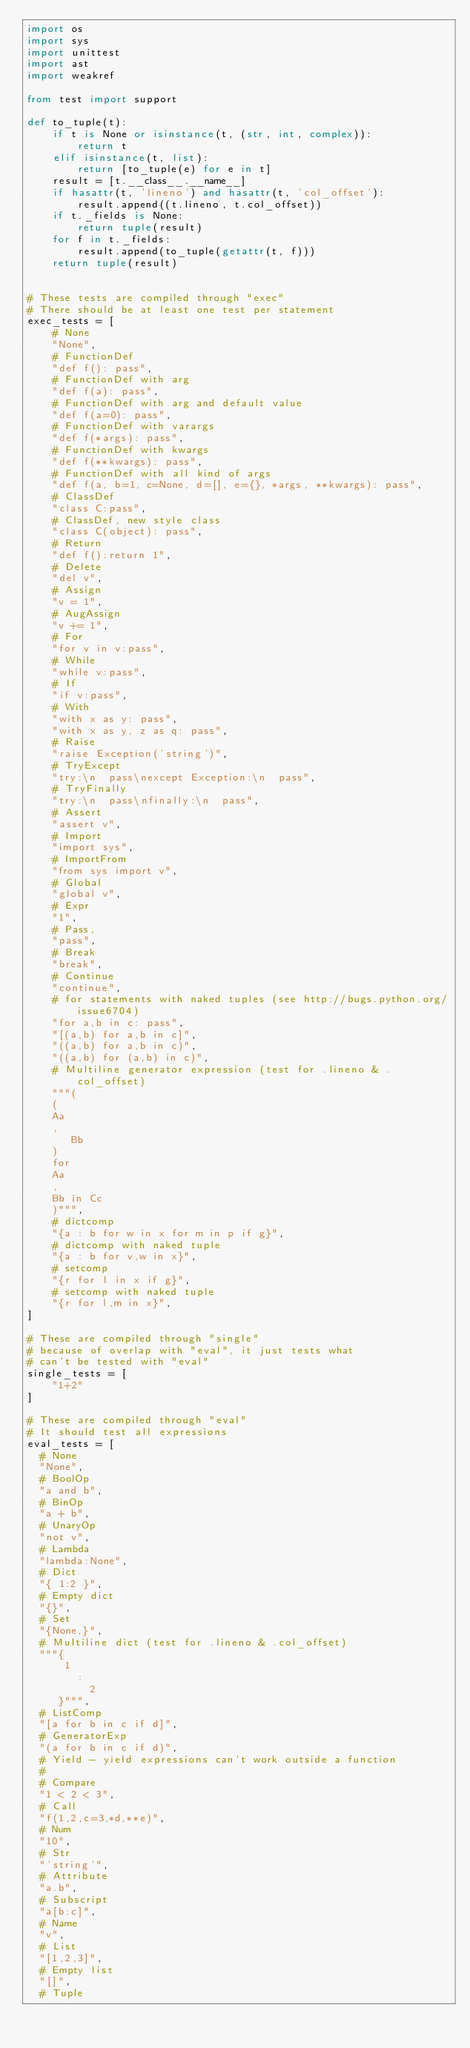<code> <loc_0><loc_0><loc_500><loc_500><_Python_>import os
import sys
import unittest
import ast
import weakref

from test import support

def to_tuple(t):
    if t is None or isinstance(t, (str, int, complex)):
        return t
    elif isinstance(t, list):
        return [to_tuple(e) for e in t]
    result = [t.__class__.__name__]
    if hasattr(t, 'lineno') and hasattr(t, 'col_offset'):
        result.append((t.lineno, t.col_offset))
    if t._fields is None:
        return tuple(result)
    for f in t._fields:
        result.append(to_tuple(getattr(t, f)))
    return tuple(result)


# These tests are compiled through "exec"
# There should be at least one test per statement
exec_tests = [
    # None
    "None",
    # FunctionDef
    "def f(): pass",
    # FunctionDef with arg
    "def f(a): pass",
    # FunctionDef with arg and default value
    "def f(a=0): pass",
    # FunctionDef with varargs
    "def f(*args): pass",
    # FunctionDef with kwargs
    "def f(**kwargs): pass",
    # FunctionDef with all kind of args
    "def f(a, b=1, c=None, d=[], e={}, *args, **kwargs): pass",
    # ClassDef
    "class C:pass",
    # ClassDef, new style class
    "class C(object): pass",
    # Return
    "def f():return 1",
    # Delete
    "del v",
    # Assign
    "v = 1",
    # AugAssign
    "v += 1",
    # For
    "for v in v:pass",
    # While
    "while v:pass",
    # If
    "if v:pass",
    # With
    "with x as y: pass",
    "with x as y, z as q: pass",
    # Raise
    "raise Exception('string')",
    # TryExcept
    "try:\n  pass\nexcept Exception:\n  pass",
    # TryFinally
    "try:\n  pass\nfinally:\n  pass",
    # Assert
    "assert v",
    # Import
    "import sys",
    # ImportFrom
    "from sys import v",
    # Global
    "global v",
    # Expr
    "1",
    # Pass,
    "pass",
    # Break
    "break",
    # Continue
    "continue",
    # for statements with naked tuples (see http://bugs.python.org/issue6704)
    "for a,b in c: pass",
    "[(a,b) for a,b in c]",
    "((a,b) for a,b in c)",
    "((a,b) for (a,b) in c)",
    # Multiline generator expression (test for .lineno & .col_offset)
    """(
    (
    Aa
    ,
       Bb
    )
    for
    Aa
    ,
    Bb in Cc
    )""",
    # dictcomp
    "{a : b for w in x for m in p if g}",
    # dictcomp with naked tuple
    "{a : b for v,w in x}",
    # setcomp
    "{r for l in x if g}",
    # setcomp with naked tuple
    "{r for l,m in x}",
]

# These are compiled through "single"
# because of overlap with "eval", it just tests what
# can't be tested with "eval"
single_tests = [
    "1+2"
]

# These are compiled through "eval"
# It should test all expressions
eval_tests = [
  # None
  "None",
  # BoolOp
  "a and b",
  # BinOp
  "a + b",
  # UnaryOp
  "not v",
  # Lambda
  "lambda:None",
  # Dict
  "{ 1:2 }",
  # Empty dict
  "{}",
  # Set
  "{None,}",
  # Multiline dict (test for .lineno & .col_offset)
  """{
      1
        :
          2
     }""",
  # ListComp
  "[a for b in c if d]",
  # GeneratorExp
  "(a for b in c if d)",
  # Yield - yield expressions can't work outside a function
  #
  # Compare
  "1 < 2 < 3",
  # Call
  "f(1,2,c=3,*d,**e)",
  # Num
  "10",
  # Str
  "'string'",
  # Attribute
  "a.b",
  # Subscript
  "a[b:c]",
  # Name
  "v",
  # List
  "[1,2,3]",
  # Empty list
  "[]",
  # Tuple</code> 